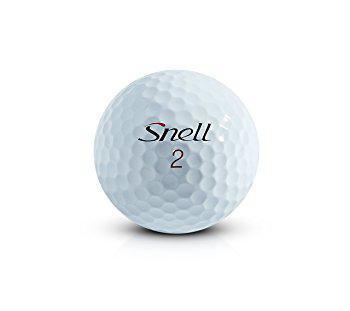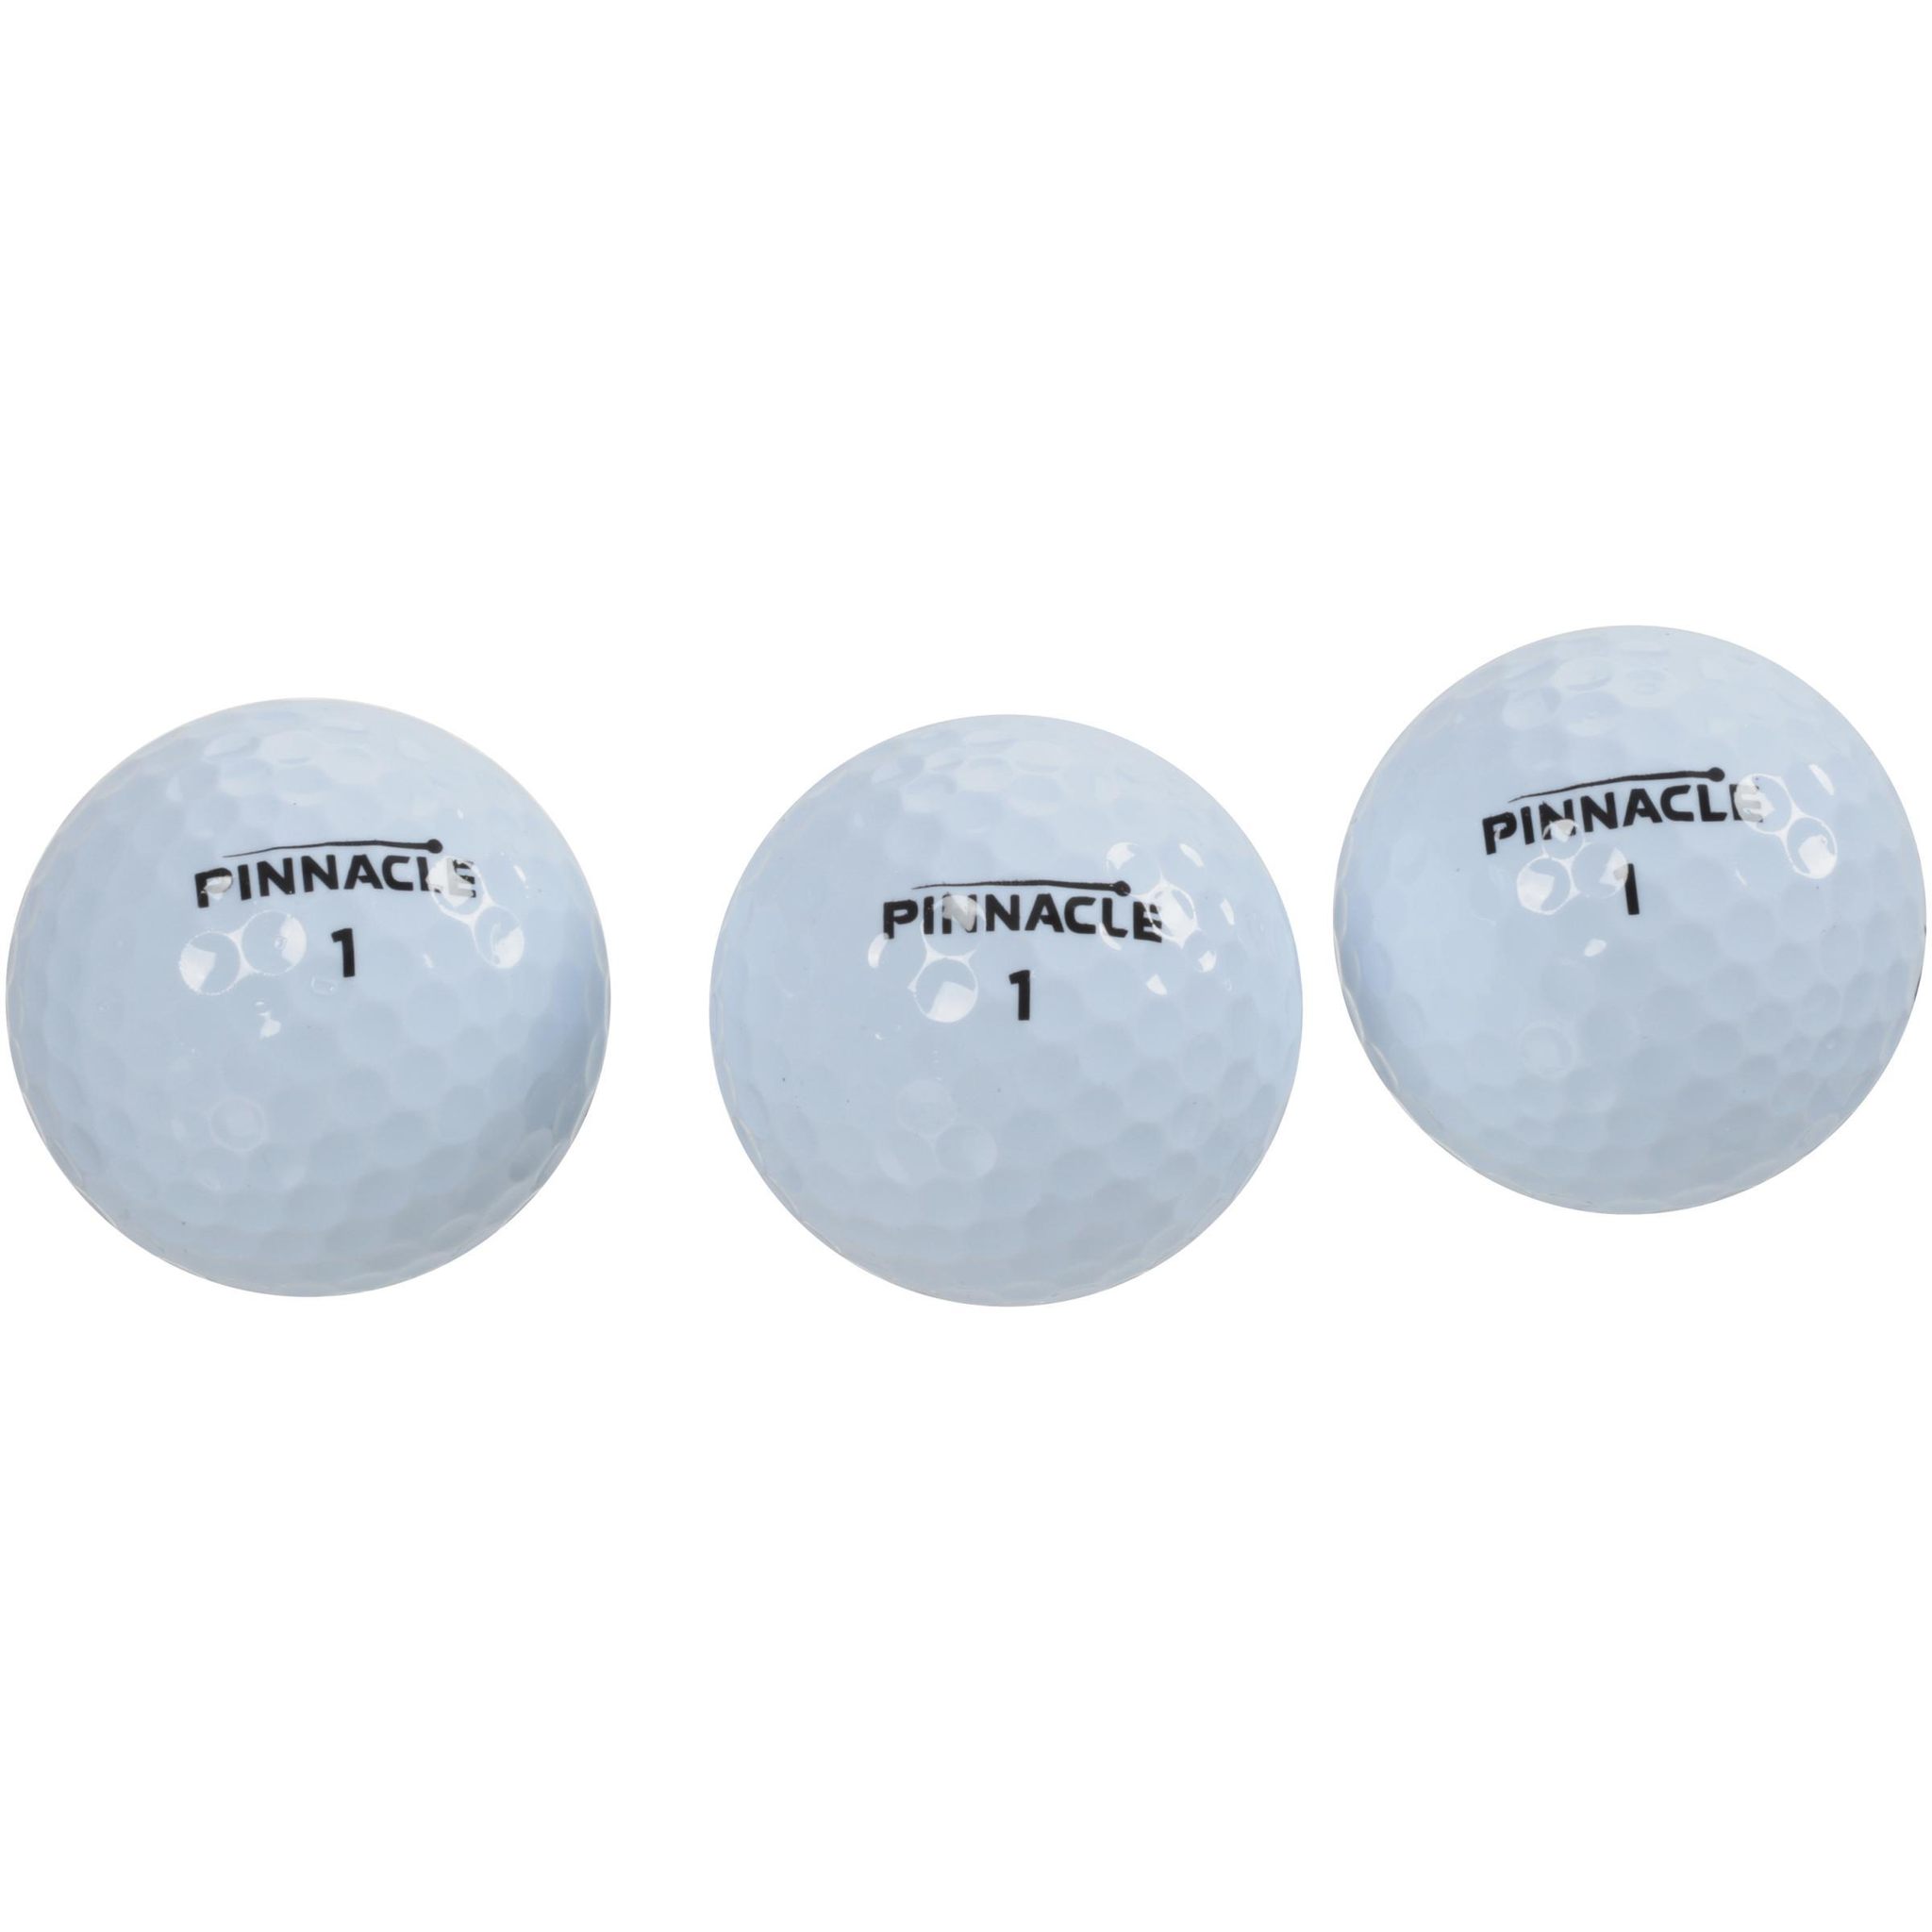The first image is the image on the left, the second image is the image on the right. Examine the images to the left and right. Is the description "The left and right image contains a total of four golf balls." accurate? Answer yes or no. Yes. The first image is the image on the left, the second image is the image on the right. Examine the images to the left and right. Is the description "There's three golf balls in one image and one in the other image." accurate? Answer yes or no. Yes. 